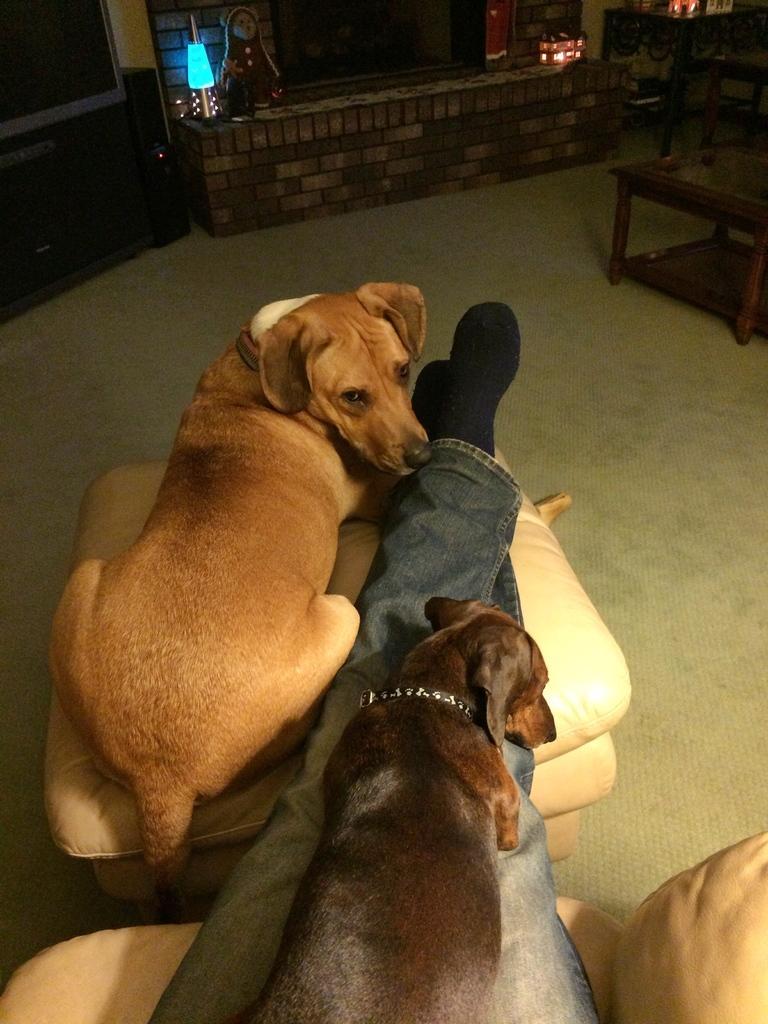Describe this image in one or two sentences. In this picture we can see a small wall with bricks and on the wall we can see light in blue colour. This is a floor. Here we can see two dogs and one dog is on the legs of a human. It is sitting. This is a television. This is a table and chair. 